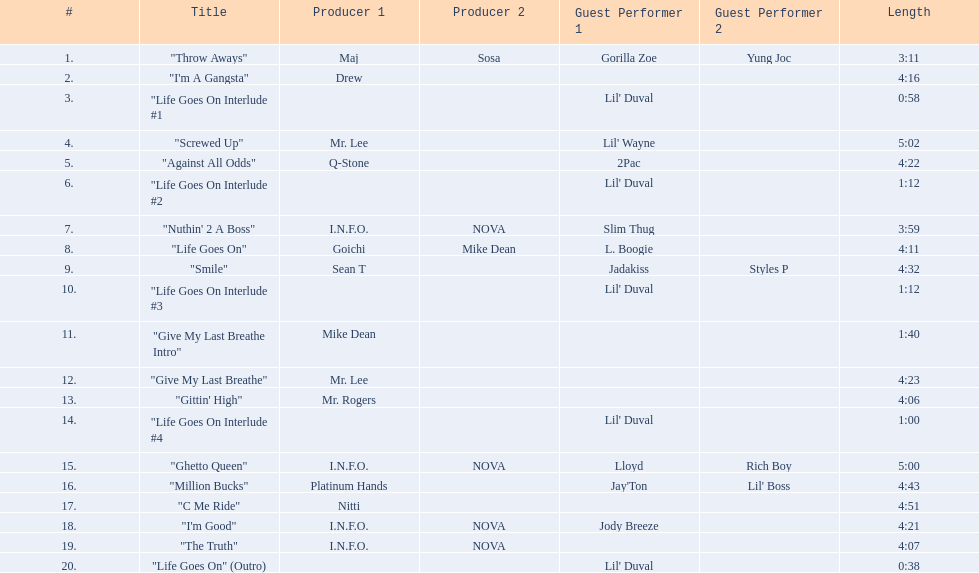What are the song lengths of all the songs on the album? 3:11, 4:16, 0:58, 5:02, 4:22, 1:12, 3:59, 4:11, 4:32, 1:12, 1:40, 4:23, 4:06, 1:00, 5:00, 4:43, 4:51, 4:21, 4:07, 0:38. Which is the longest of these? 5:02. 